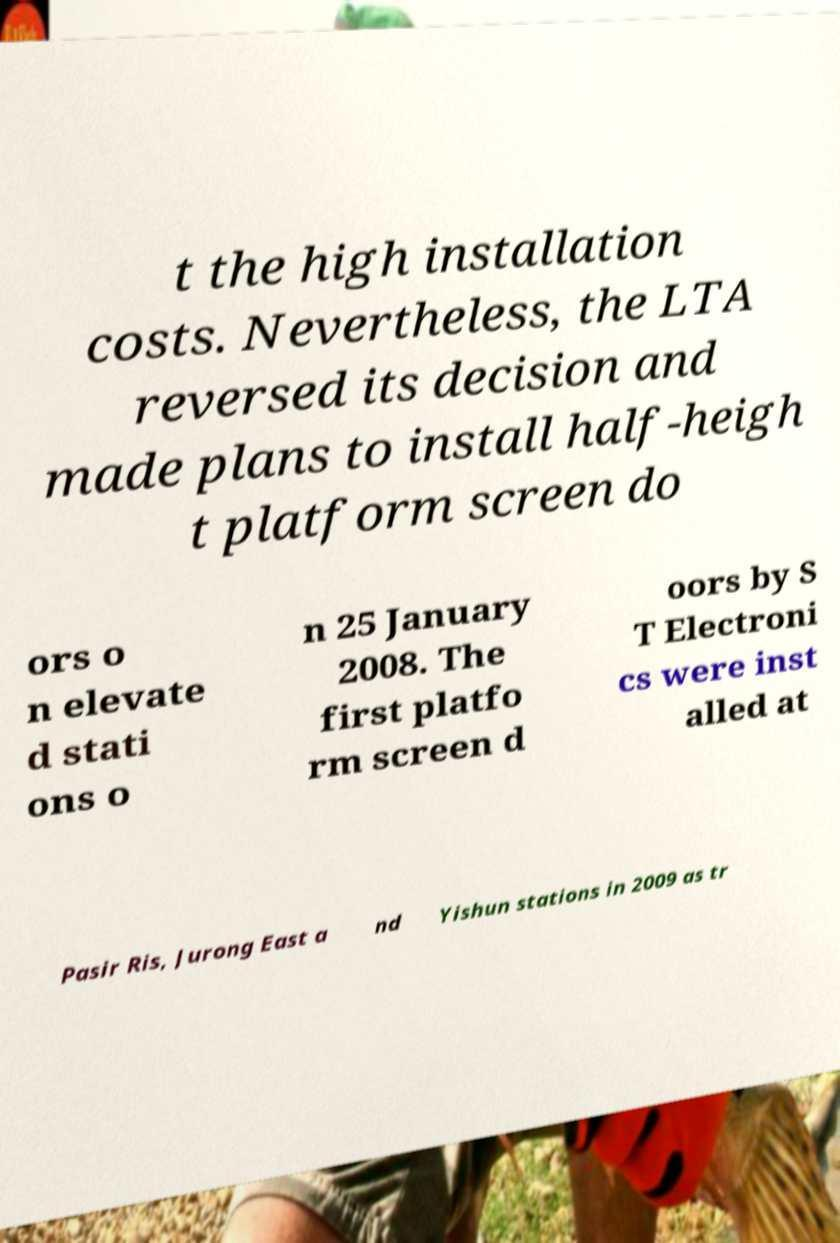Could you extract and type out the text from this image? t the high installation costs. Nevertheless, the LTA reversed its decision and made plans to install half-heigh t platform screen do ors o n elevate d stati ons o n 25 January 2008. The first platfo rm screen d oors by S T Electroni cs were inst alled at Pasir Ris, Jurong East a nd Yishun stations in 2009 as tr 